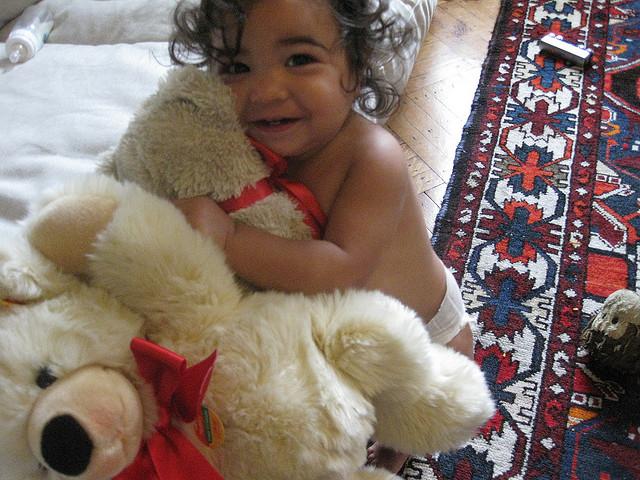Do you see a feeding item in this photo?
Keep it brief. Yes. What is the baby holding?
Short answer required. Teddy bear. Curly hair or straight hair?
Short answer required. Curly. 